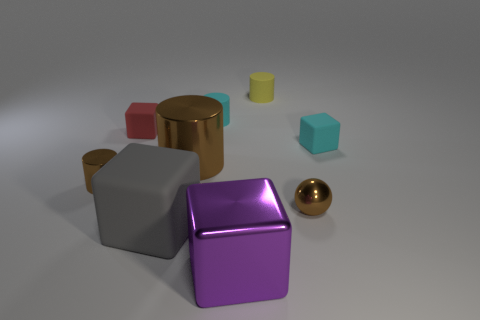There is a big brown object that is the same shape as the yellow object; what material is it?
Your answer should be compact. Metal. The small object that is the same color as the small shiny cylinder is what shape?
Make the answer very short. Sphere. The sphere that is the same material as the large purple object is what size?
Your response must be concise. Small. Is the number of matte cylinders left of the gray matte thing greater than the number of gray things?
Offer a terse response. No. There is a large gray thing; is its shape the same as the small cyan thing that is left of the small ball?
Make the answer very short. No. How many large things are matte blocks or matte cylinders?
Keep it short and to the point. 1. What size is the other cylinder that is the same color as the big metal cylinder?
Give a very brief answer. Small. There is a tiny shiny object on the left side of the big cube that is right of the cyan cylinder; what is its color?
Make the answer very short. Brown. Are the ball and the tiny cyan object on the right side of the small shiny ball made of the same material?
Your response must be concise. No. There is a tiny cylinder to the left of the large brown metal cylinder; what material is it?
Ensure brevity in your answer.  Metal. 